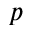Convert formula to latex. <formula><loc_0><loc_0><loc_500><loc_500>p</formula> 